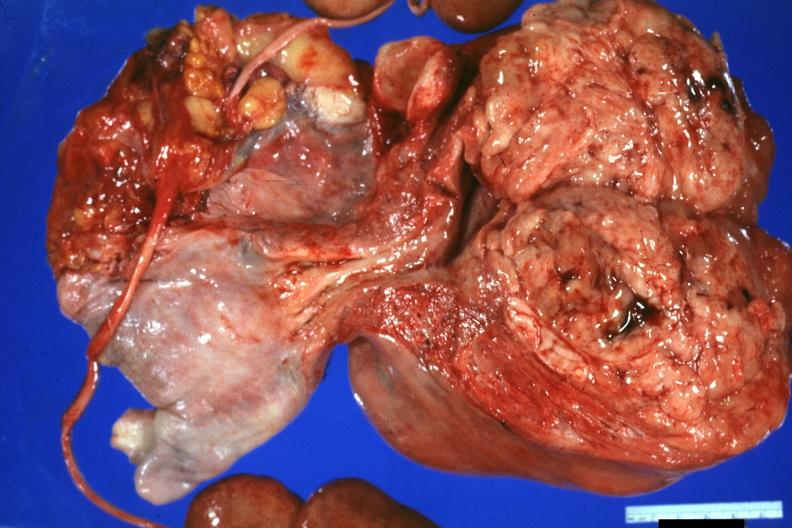s surface present?
Answer the question using a single word or phrase. No 